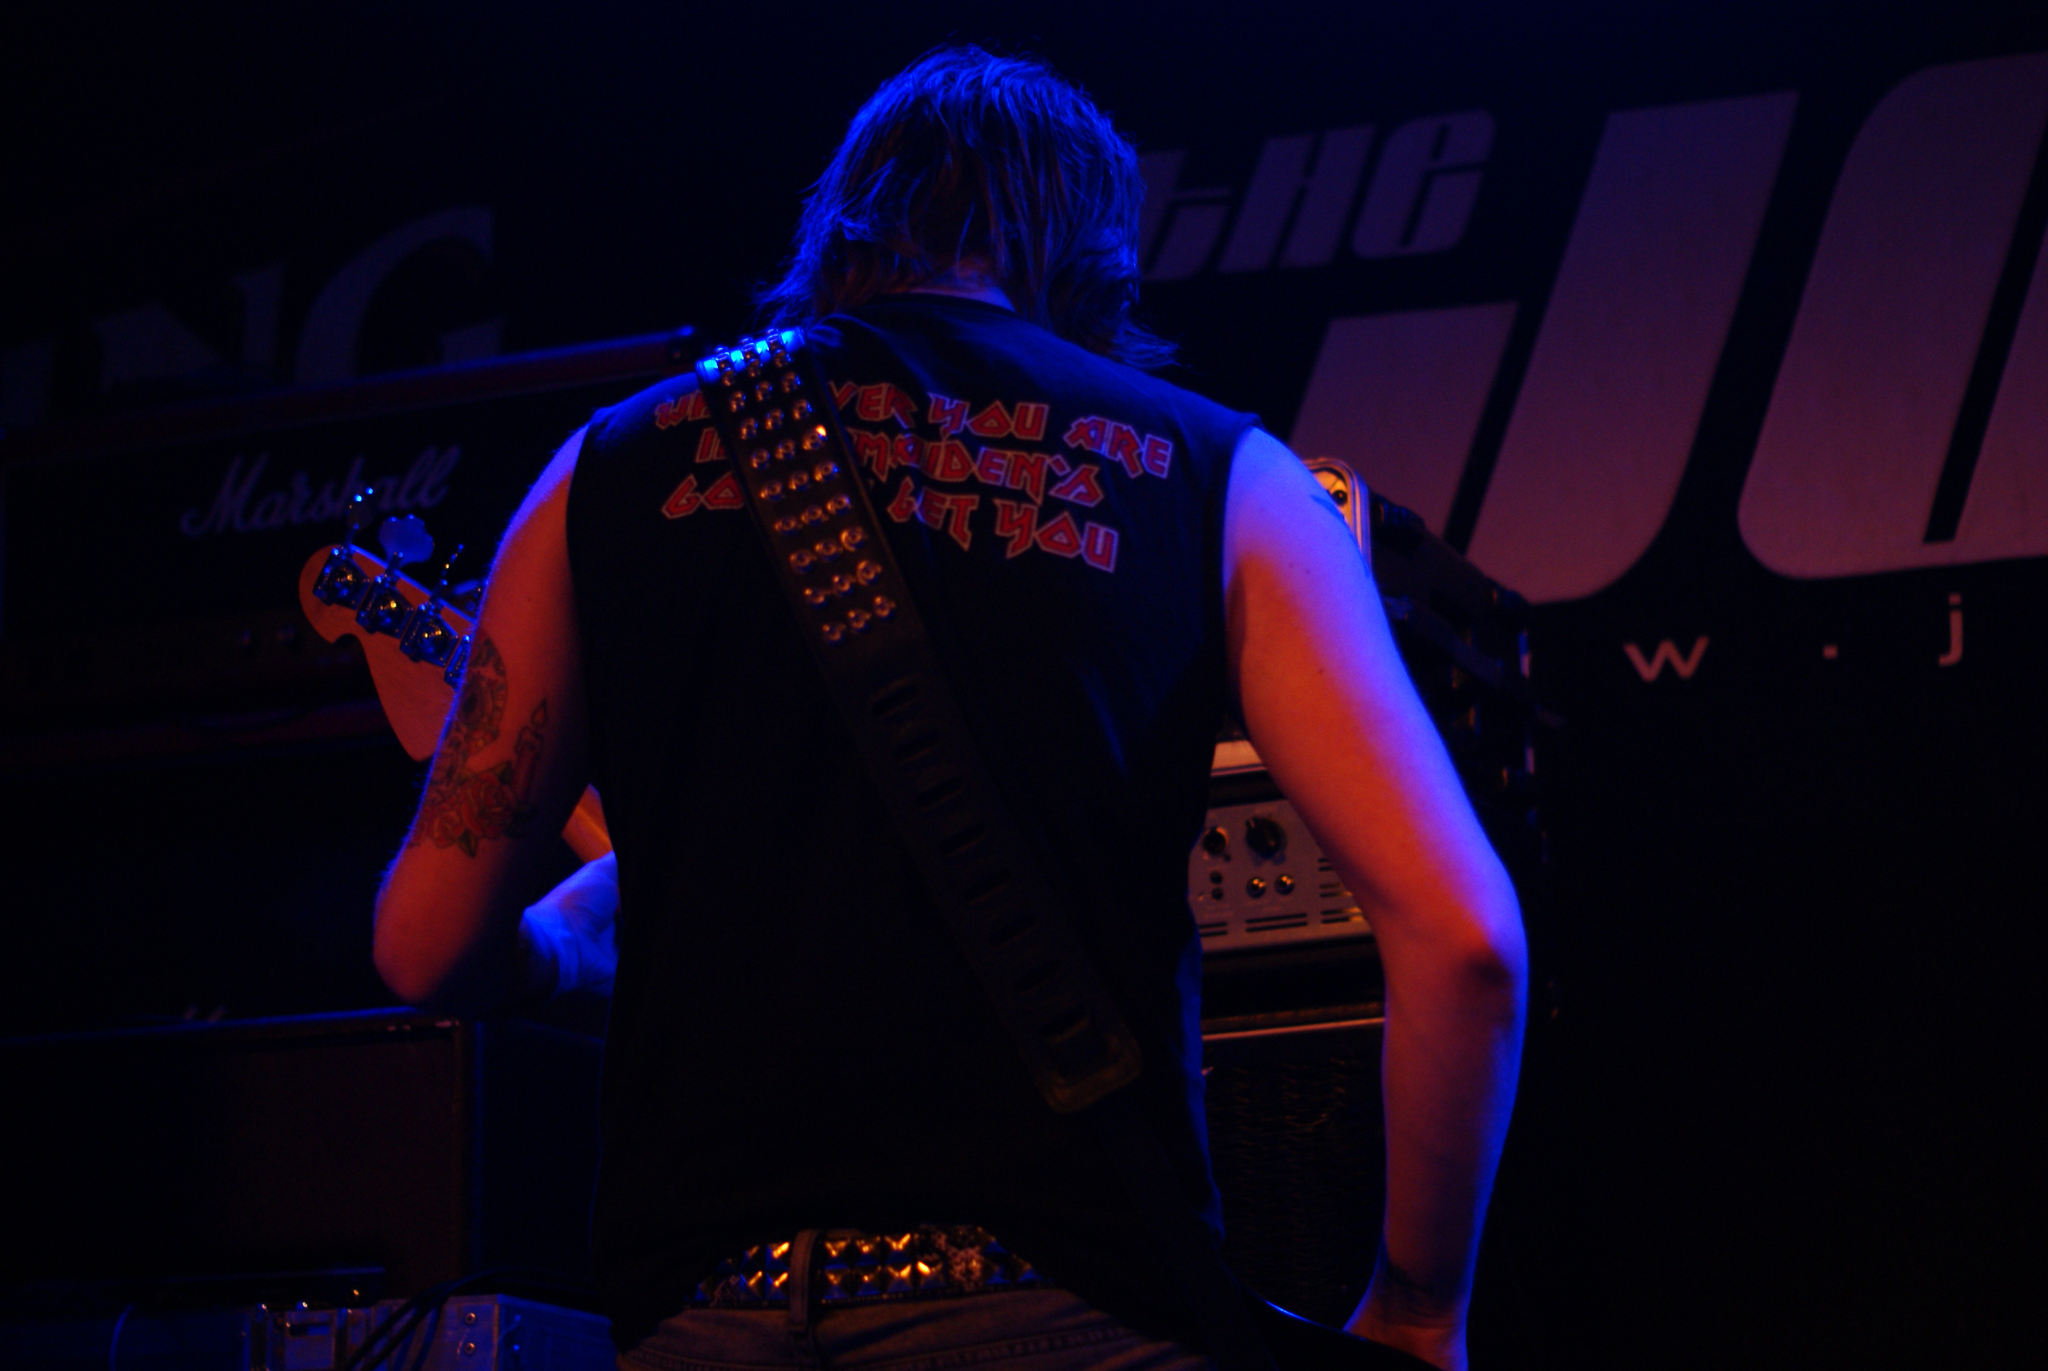Please provide a concise description of this image. This man is standing and worn guitar. On this table there are devices. 